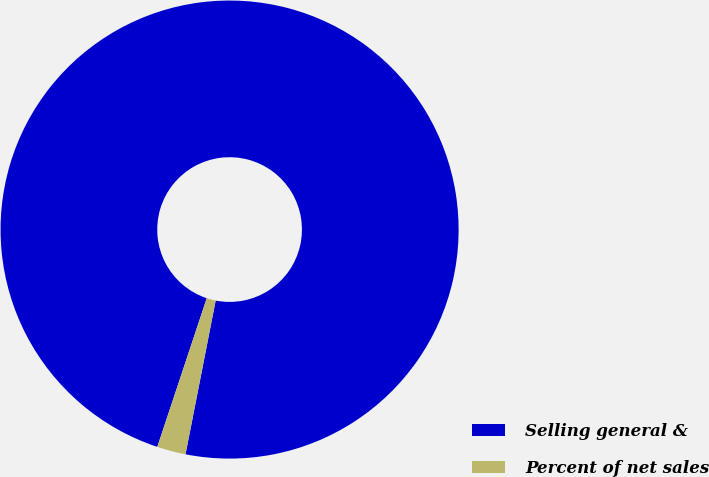Convert chart to OTSL. <chart><loc_0><loc_0><loc_500><loc_500><pie_chart><fcel>Selling general &<fcel>Percent of net sales<nl><fcel>97.97%<fcel>2.03%<nl></chart> 